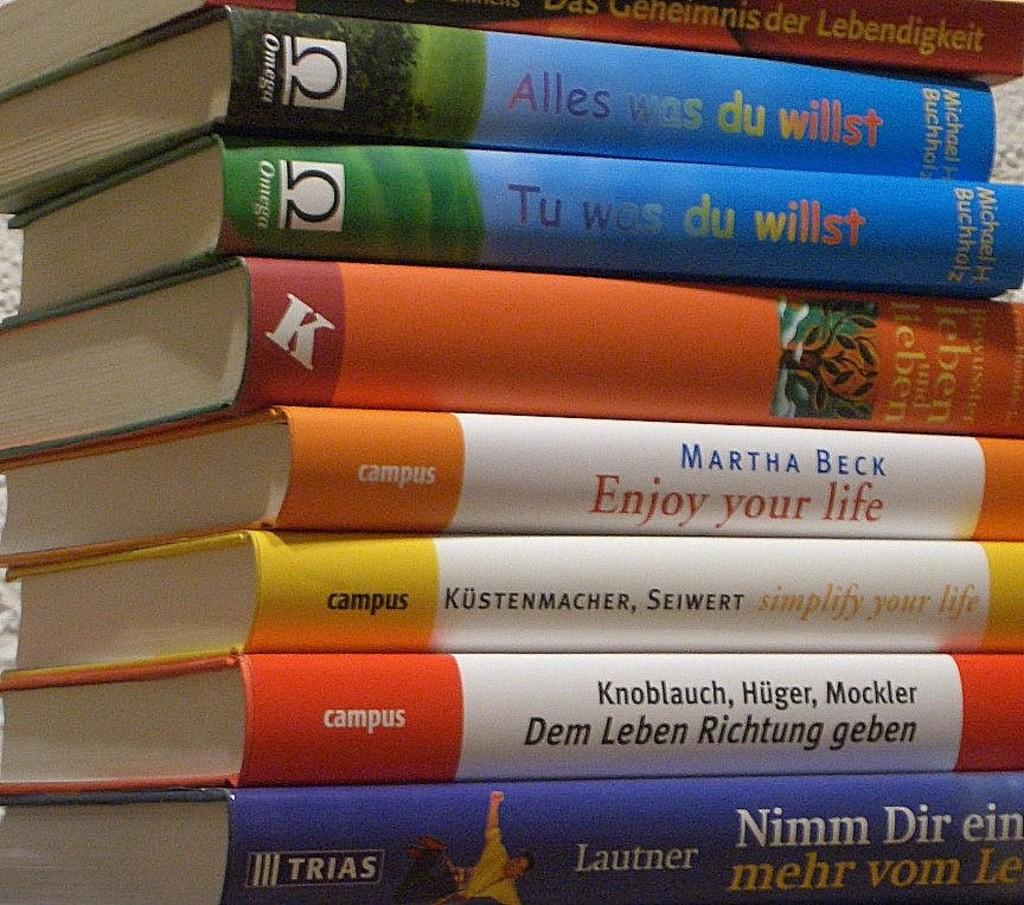<image>
Create a compact narrative representing the image presented. a stack of books that mostly say campus on the top of the spine 